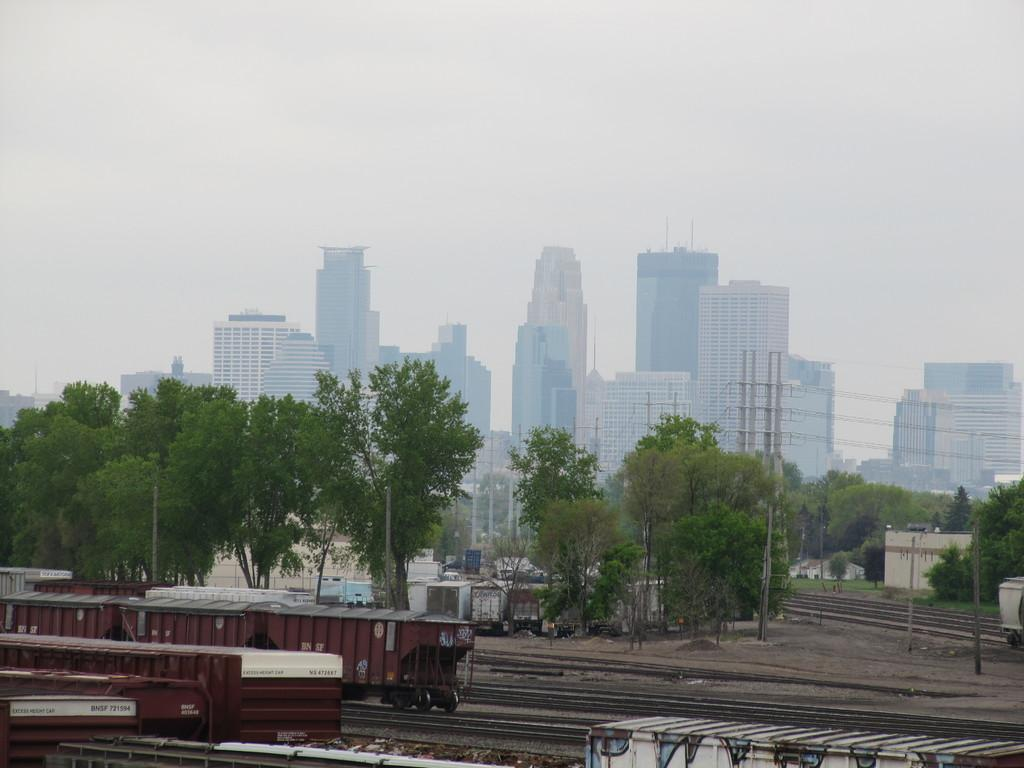What type of structures can be seen in the image? There are many buildings in the image. What else can be seen in the image besides buildings? There are trees, poles, electric wires, and trains on tracks in the image. What is visible in the sky in the image? The sky is visible in the image. What type of button can be seen on the baseball in the image? There is no button or baseball present in the image. What type of structure is the button attached to in the image? There is no button or structure with a button in the image. 